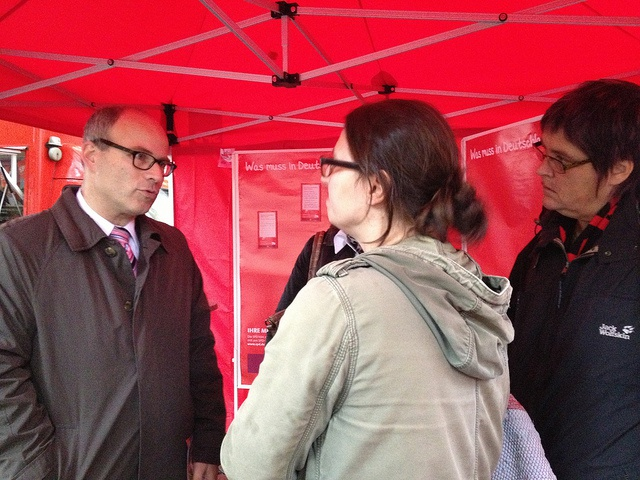Describe the objects in this image and their specific colors. I can see people in red, darkgray, ivory, tan, and lightgray tones, people in red, black, gray, maroon, and salmon tones, people in red, black, maroon, and brown tones, handbag in red, darkgray, black, and gray tones, and people in red, black, maroon, lightgray, and brown tones in this image. 